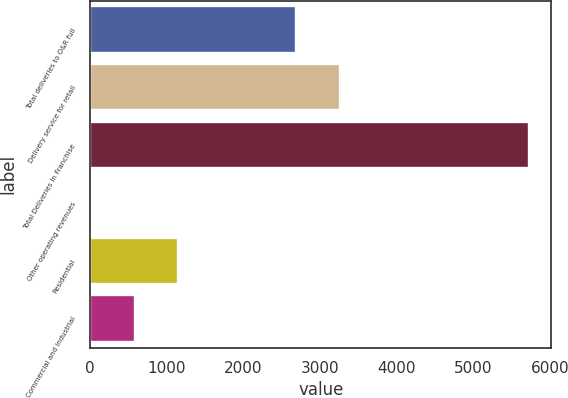<chart> <loc_0><loc_0><loc_500><loc_500><bar_chart><fcel>Total deliveries to O&R full<fcel>Delivery service for retail<fcel>Total Deliveries In Franchise<fcel>Other operating revenues<fcel>Residential<fcel>Commercial and Industrial<nl><fcel>2691<fcel>3263.2<fcel>5731<fcel>9<fcel>1153.4<fcel>581.2<nl></chart> 